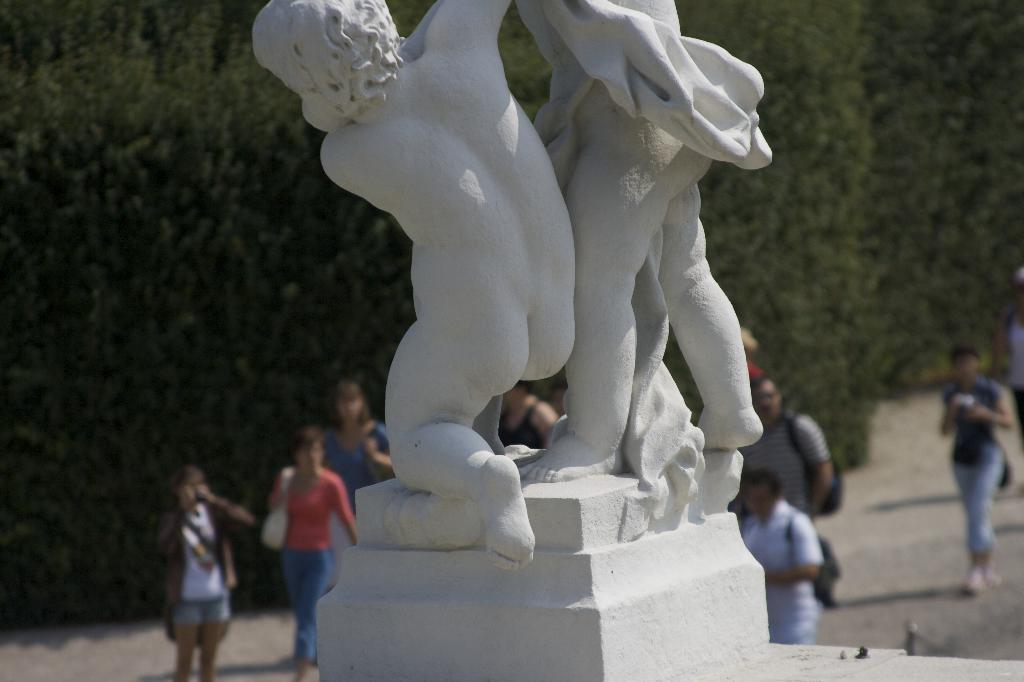What is the main subject of the image? The main subject of the image is a statue of two persons. What is the color of the statue? The statue is white in color. What can be seen in the background of the image? There are people walking and trees visible in the background of the image. What type of celery is being used as a prop by the statue in the image? There is no celery present in the image; the statue is of two persons and does not involve any celery. 